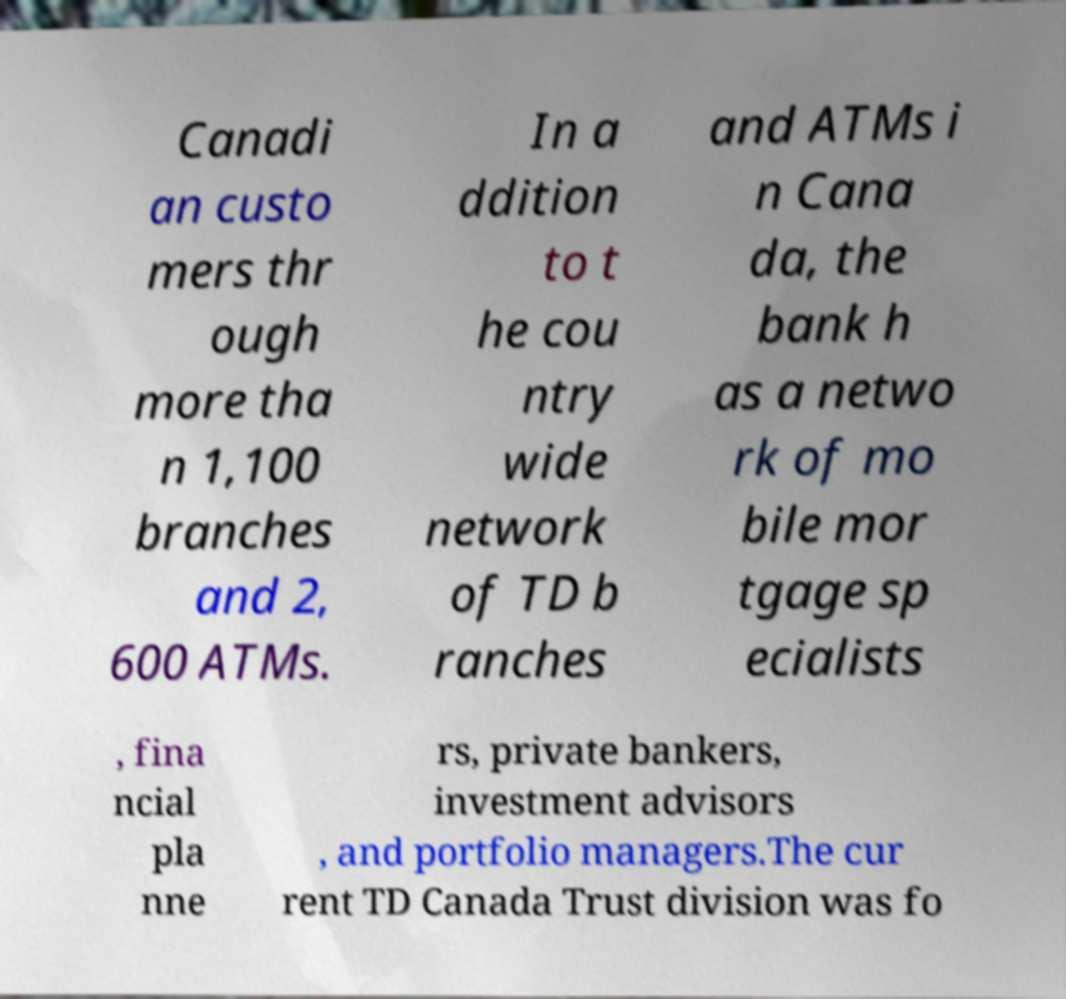Can you read and provide the text displayed in the image?This photo seems to have some interesting text. Can you extract and type it out for me? Canadi an custo mers thr ough more tha n 1,100 branches and 2, 600 ATMs. In a ddition to t he cou ntry wide network of TD b ranches and ATMs i n Cana da, the bank h as a netwo rk of mo bile mor tgage sp ecialists , fina ncial pla nne rs, private bankers, investment advisors , and portfolio managers.The cur rent TD Canada Trust division was fo 